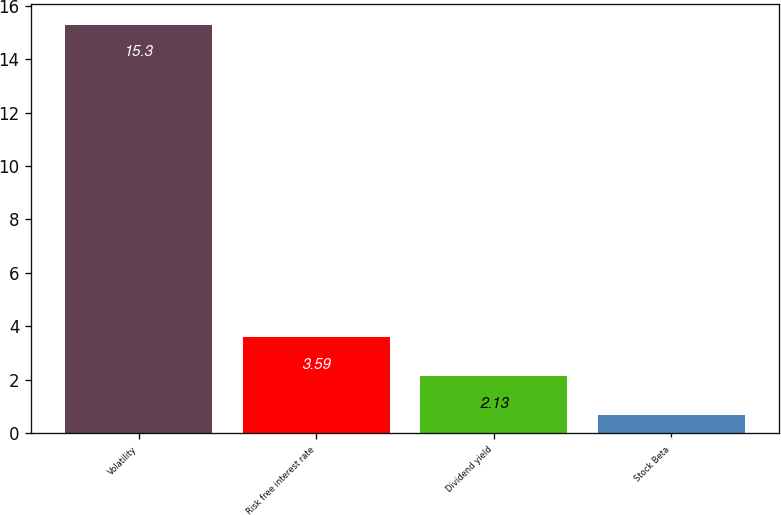<chart> <loc_0><loc_0><loc_500><loc_500><bar_chart><fcel>Volatility<fcel>Risk free interest rate<fcel>Dividend yield<fcel>Stock Beta<nl><fcel>15.3<fcel>3.59<fcel>2.13<fcel>0.67<nl></chart> 